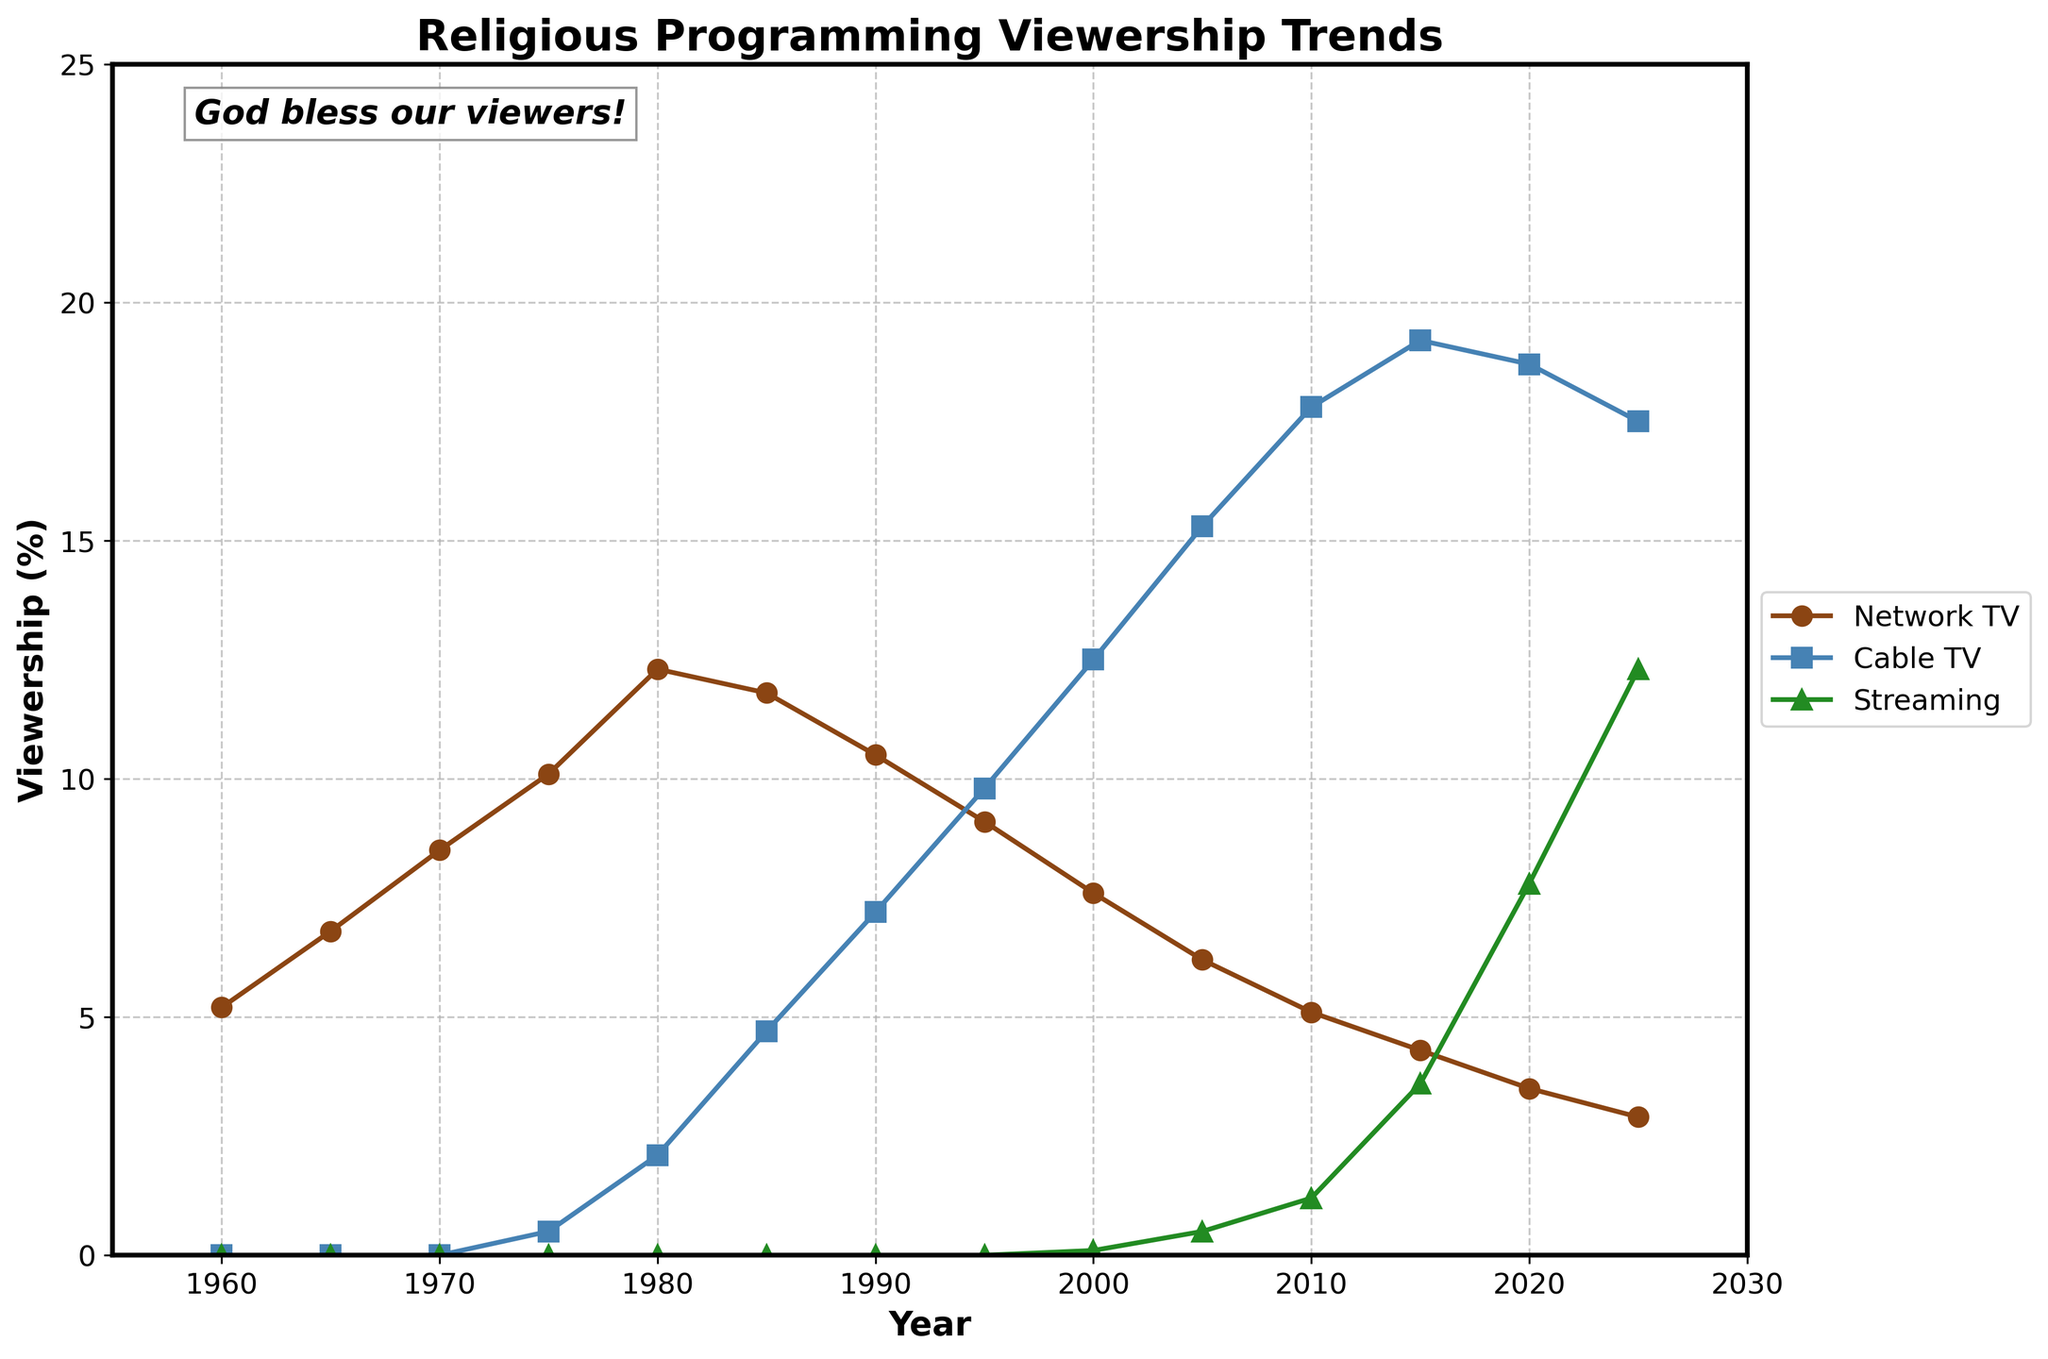What is the trend of Network TV Religious Programming viewership from 1960 to 2025? The Network TV Religious Programming viewership starts at 5.2% in 1960, rises to a peak of 12.3% in 1980, and then shows a general decline to 2.9% in 2025.
Answer: General decline after 1980 Which year had the highest viewership for Cable TV Religious Programming? The viewership for Cable TV Religious Programming is highest in 2015, with a value of 19.2%.
Answer: 2015 How does the viewership percentage of Streaming Religious Content in 2025 compare to Network TV in 1980? The Streaming Religious Content viewership in 2025 (12.3%) is exactly equal to the Network TV viewership in 1980 (12.3%).
Answer: Equal In which year did Cable TV Religious Programming surpass Network TV Religious Programming? Cable TV Religious Programming first surpasses Network TV Religious Programming in 1990.
Answer: 1990 What is the difference in viewership between Network TV and Cable TV Religious Programming in 2000? In 2000, Network TV Religious Programming is at 7.6% while Cable TV is at 12.5%. The difference is 12.5% - 7.6% = 4.9%.
Answer: 4.9% Calculate the average viewership percentage for Streaming Religious Content from 2000 to 2025. The viewership values for Streaming Religious Content from 2000 to 2025 are 0.1, 0.5, 1.2, 3.6, 7.8, and 12.3. The average is (0.1 + 0.5 + 1.2 + 3.6 + 7.8 + 12.3) / 6 = 25.5 / 6 = 4.25%.
Answer: 4.25% What is the viewership percentage difference between Cable TV and Streaming Religious Content in 2020? Cable TV Religious Programming in 2020 is at 18.7%, and Streaming Religious Content is at 7.8%. The difference is 18.7% - 7.8% = 10.9%.
Answer: 10.9% Which platform showed the most significant increase in viewership from 2000 to 2025? Streaming Religious Content increased from 0.1% in 2000 to 12.3% in 2025, an increase of 12.2%. Network TV and Cable TV saw declines.
Answer: Streaming 